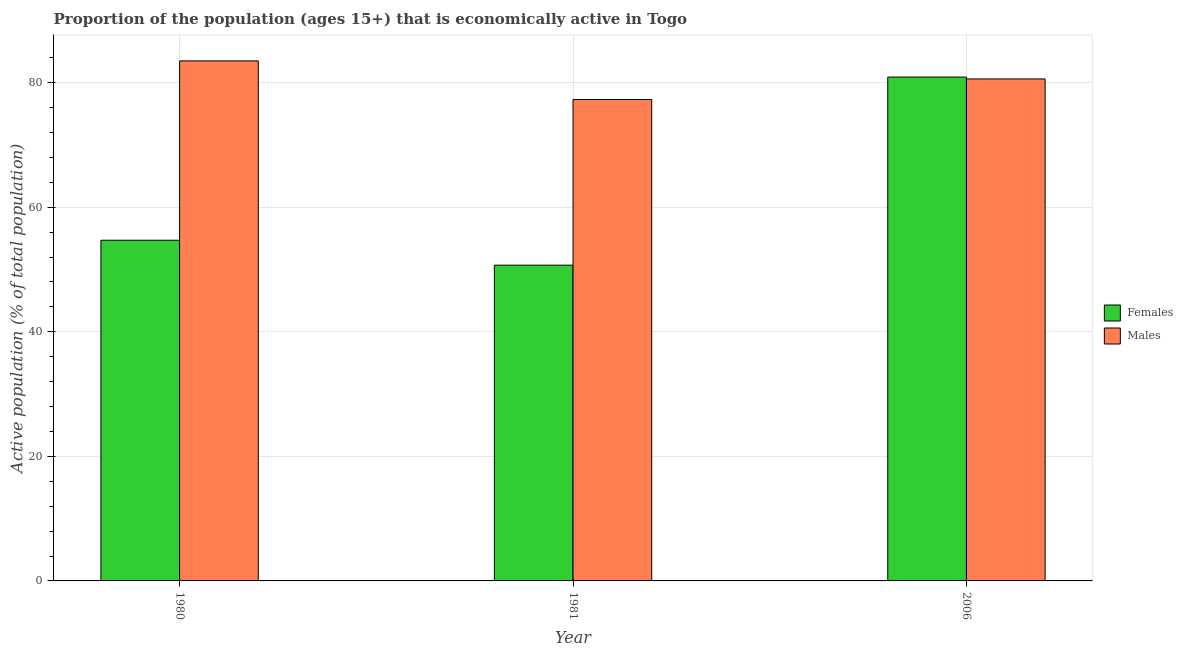How many groups of bars are there?
Keep it short and to the point. 3. How many bars are there on the 3rd tick from the left?
Make the answer very short. 2. What is the label of the 1st group of bars from the left?
Your answer should be very brief. 1980. What is the percentage of economically active female population in 2006?
Offer a very short reply. 80.9. Across all years, what is the maximum percentage of economically active female population?
Provide a succinct answer. 80.9. Across all years, what is the minimum percentage of economically active male population?
Provide a succinct answer. 77.3. In which year was the percentage of economically active male population minimum?
Your answer should be compact. 1981. What is the total percentage of economically active female population in the graph?
Your response must be concise. 186.3. What is the difference between the percentage of economically active male population in 1980 and that in 2006?
Ensure brevity in your answer.  2.9. What is the difference between the percentage of economically active male population in 1980 and the percentage of economically active female population in 2006?
Your answer should be very brief. 2.9. What is the average percentage of economically active female population per year?
Offer a terse response. 62.1. In how many years, is the percentage of economically active male population greater than 48 %?
Your response must be concise. 3. What is the ratio of the percentage of economically active male population in 1980 to that in 2006?
Make the answer very short. 1.04. Is the difference between the percentage of economically active female population in 1981 and 2006 greater than the difference between the percentage of economically active male population in 1981 and 2006?
Offer a terse response. No. What is the difference between the highest and the second highest percentage of economically active male population?
Your answer should be very brief. 2.9. What is the difference between the highest and the lowest percentage of economically active female population?
Provide a succinct answer. 30.2. What does the 1st bar from the left in 2006 represents?
Your response must be concise. Females. What does the 2nd bar from the right in 2006 represents?
Keep it short and to the point. Females. How many bars are there?
Provide a succinct answer. 6. How many years are there in the graph?
Offer a terse response. 3. What is the difference between two consecutive major ticks on the Y-axis?
Your answer should be very brief. 20. Are the values on the major ticks of Y-axis written in scientific E-notation?
Your answer should be compact. No. Does the graph contain grids?
Your answer should be very brief. Yes. How many legend labels are there?
Give a very brief answer. 2. How are the legend labels stacked?
Your response must be concise. Vertical. What is the title of the graph?
Offer a very short reply. Proportion of the population (ages 15+) that is economically active in Togo. Does "Primary education" appear as one of the legend labels in the graph?
Your answer should be compact. No. What is the label or title of the X-axis?
Your response must be concise. Year. What is the label or title of the Y-axis?
Keep it short and to the point. Active population (% of total population). What is the Active population (% of total population) of Females in 1980?
Ensure brevity in your answer.  54.7. What is the Active population (% of total population) in Males in 1980?
Your answer should be very brief. 83.5. What is the Active population (% of total population) of Females in 1981?
Offer a very short reply. 50.7. What is the Active population (% of total population) of Males in 1981?
Give a very brief answer. 77.3. What is the Active population (% of total population) in Females in 2006?
Give a very brief answer. 80.9. What is the Active population (% of total population) of Males in 2006?
Make the answer very short. 80.6. Across all years, what is the maximum Active population (% of total population) of Females?
Provide a succinct answer. 80.9. Across all years, what is the maximum Active population (% of total population) in Males?
Make the answer very short. 83.5. Across all years, what is the minimum Active population (% of total population) in Females?
Ensure brevity in your answer.  50.7. Across all years, what is the minimum Active population (% of total population) in Males?
Give a very brief answer. 77.3. What is the total Active population (% of total population) in Females in the graph?
Your response must be concise. 186.3. What is the total Active population (% of total population) of Males in the graph?
Offer a very short reply. 241.4. What is the difference between the Active population (% of total population) in Females in 1980 and that in 2006?
Ensure brevity in your answer.  -26.2. What is the difference between the Active population (% of total population) of Males in 1980 and that in 2006?
Provide a short and direct response. 2.9. What is the difference between the Active population (% of total population) of Females in 1981 and that in 2006?
Provide a short and direct response. -30.2. What is the difference between the Active population (% of total population) in Males in 1981 and that in 2006?
Provide a succinct answer. -3.3. What is the difference between the Active population (% of total population) in Females in 1980 and the Active population (% of total population) in Males in 1981?
Your answer should be very brief. -22.6. What is the difference between the Active population (% of total population) in Females in 1980 and the Active population (% of total population) in Males in 2006?
Provide a succinct answer. -25.9. What is the difference between the Active population (% of total population) in Females in 1981 and the Active population (% of total population) in Males in 2006?
Offer a terse response. -29.9. What is the average Active population (% of total population) in Females per year?
Provide a succinct answer. 62.1. What is the average Active population (% of total population) of Males per year?
Your answer should be very brief. 80.47. In the year 1980, what is the difference between the Active population (% of total population) of Females and Active population (% of total population) of Males?
Your response must be concise. -28.8. In the year 1981, what is the difference between the Active population (% of total population) of Females and Active population (% of total population) of Males?
Ensure brevity in your answer.  -26.6. In the year 2006, what is the difference between the Active population (% of total population) in Females and Active population (% of total population) in Males?
Keep it short and to the point. 0.3. What is the ratio of the Active population (% of total population) in Females in 1980 to that in 1981?
Give a very brief answer. 1.08. What is the ratio of the Active population (% of total population) of Males in 1980 to that in 1981?
Offer a very short reply. 1.08. What is the ratio of the Active population (% of total population) of Females in 1980 to that in 2006?
Your response must be concise. 0.68. What is the ratio of the Active population (% of total population) of Males in 1980 to that in 2006?
Provide a succinct answer. 1.04. What is the ratio of the Active population (% of total population) in Females in 1981 to that in 2006?
Your answer should be compact. 0.63. What is the ratio of the Active population (% of total population) of Males in 1981 to that in 2006?
Your answer should be very brief. 0.96. What is the difference between the highest and the second highest Active population (% of total population) of Females?
Offer a terse response. 26.2. What is the difference between the highest and the lowest Active population (% of total population) of Females?
Your answer should be compact. 30.2. What is the difference between the highest and the lowest Active population (% of total population) in Males?
Your answer should be very brief. 6.2. 